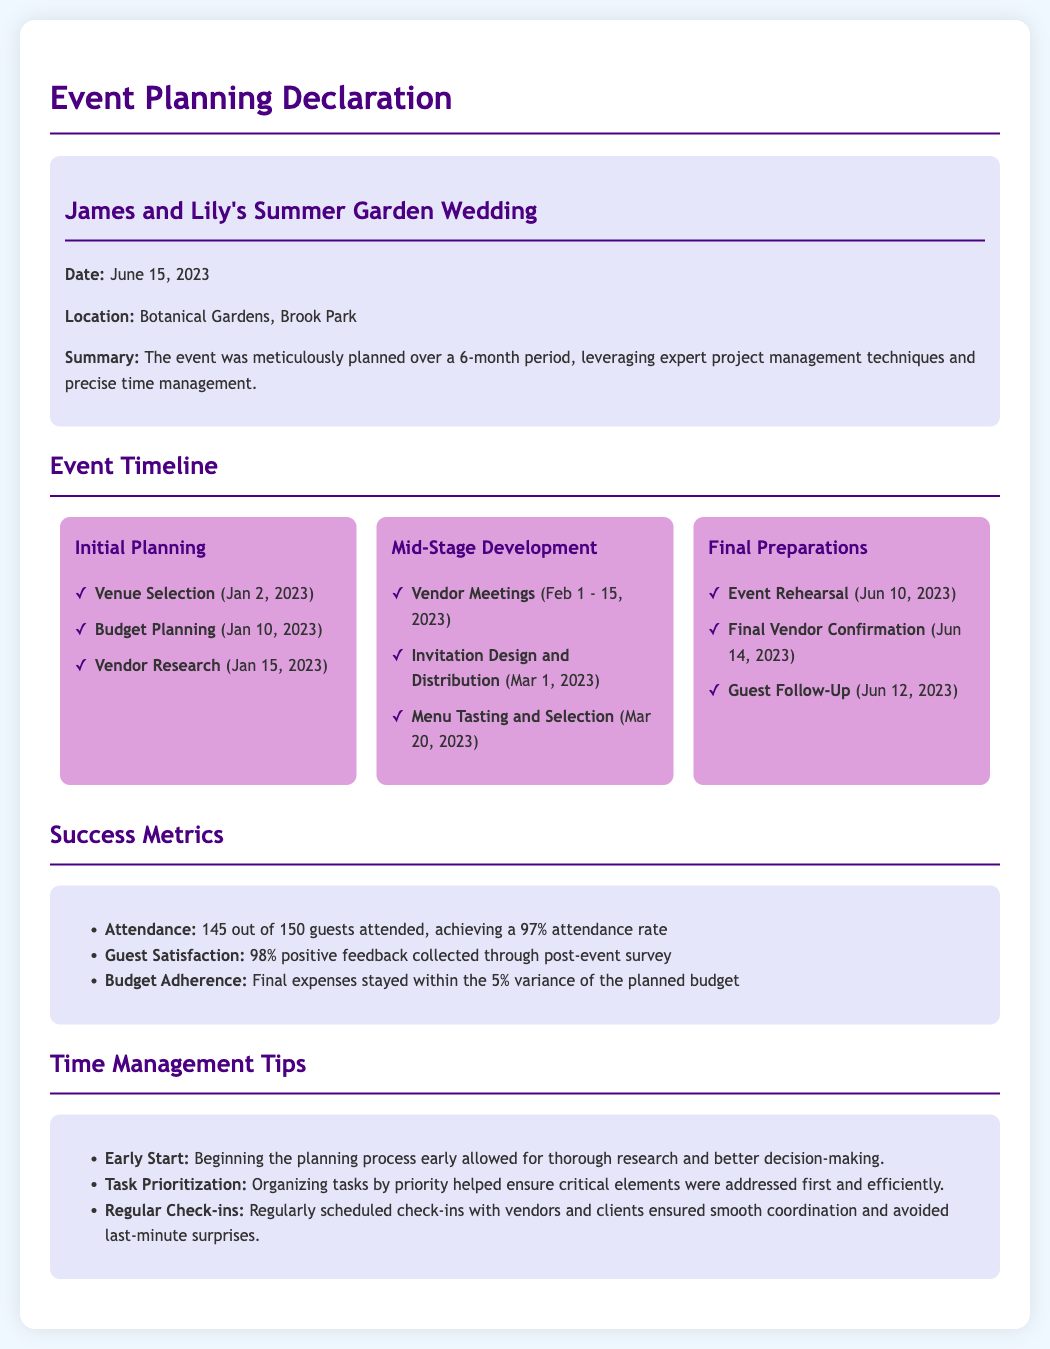What was the event? The document describes a wedding event that took place, specifically James and Lily's Summer Garden Wedding.
Answer: James and Lily's Summer Garden Wedding What was the date of the event? The document states that the event occurred on June 15, 2023.
Answer: June 15, 2023 What was the venue for the event? The venue for the wedding as mentioned in the document is the Botanical Gardens in Brook Park.
Answer: Botanical Gardens, Brook Park How many guests attended the event? The document reports that 145 out of 150 guests attended, thus providing the attendance figure.
Answer: 145 What percentage of guests were satisfied with the event? The document indicates that 98% positive feedback was collected through a post-event survey.
Answer: 98% What was the budget variance percentage? According to the document, the final expenses remained within a 5% variance of the planned budget.
Answer: 5% What was a key time management strategy used? The document highlights the importance of an early start in the planning process as a key strategy.
Answer: Early Start What task was completed on March 1, 2023? The document lists "Invitation Design and Distribution" as a task conducted on this date.
Answer: Invitation Design and Distribution What is the total count of tasks under "Final Preparations"? The document lists three tasks that fall under the "Final Preparations" stage.
Answer: 3 